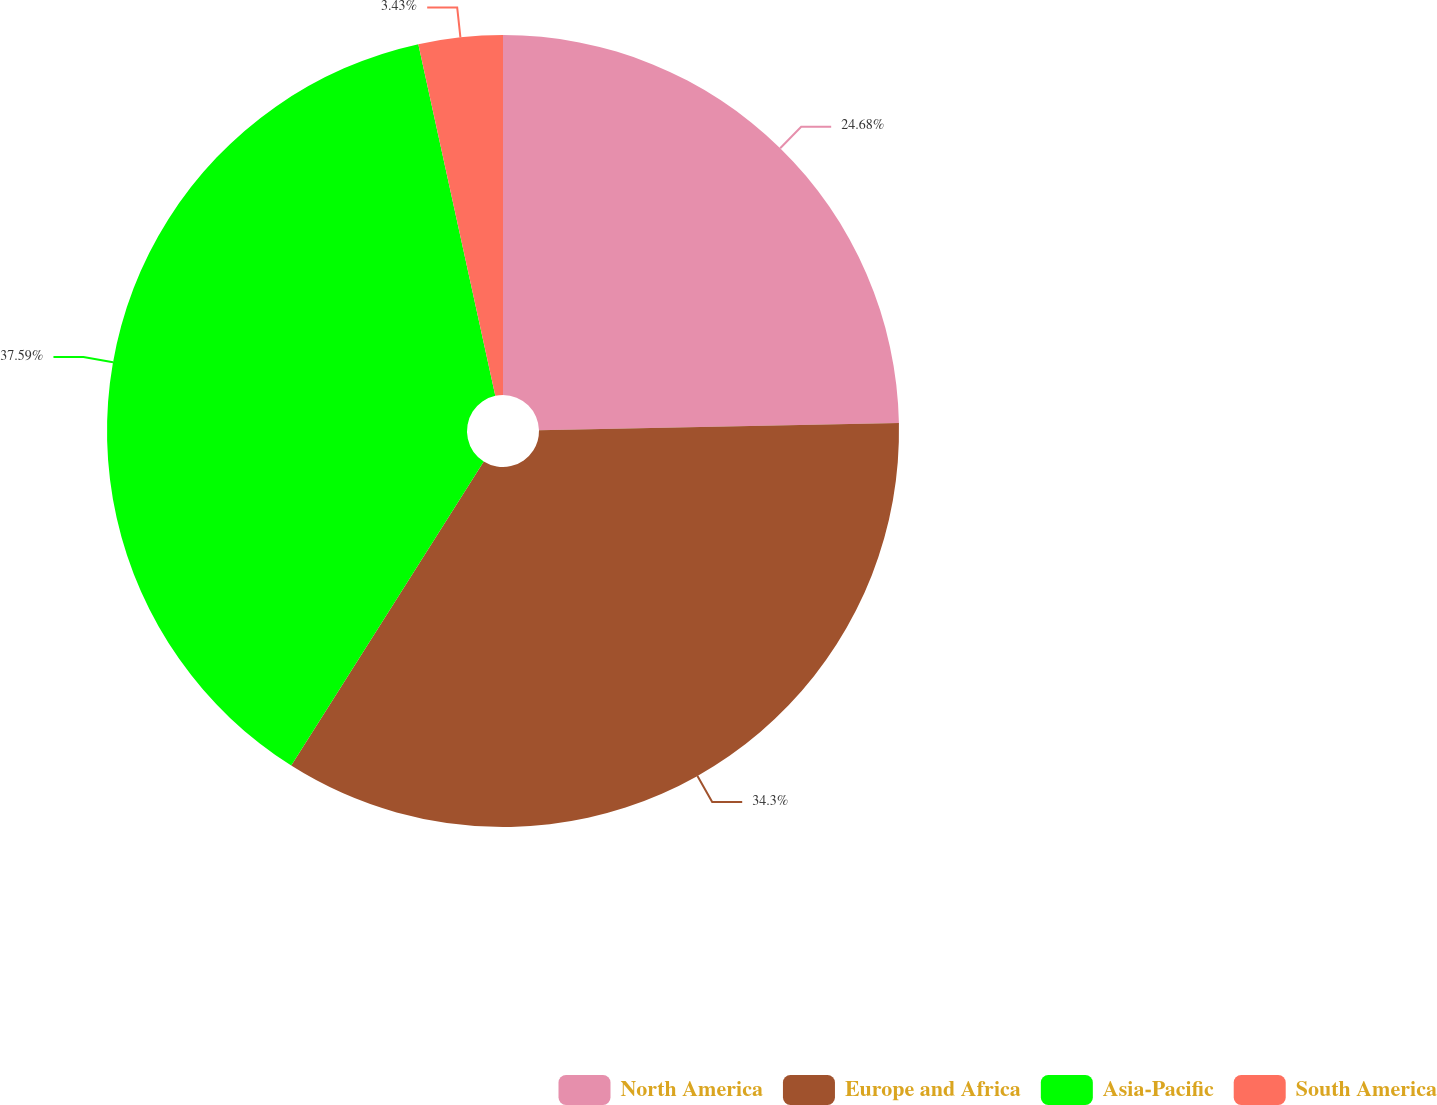Convert chart to OTSL. <chart><loc_0><loc_0><loc_500><loc_500><pie_chart><fcel>North America<fcel>Europe and Africa<fcel>Asia-Pacific<fcel>South America<nl><fcel>24.68%<fcel>34.3%<fcel>37.59%<fcel>3.43%<nl></chart> 